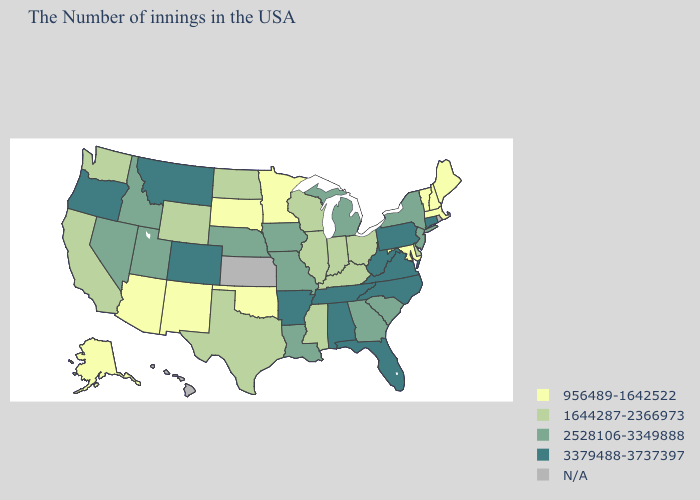What is the value of Missouri?
Answer briefly. 2528106-3349888. Name the states that have a value in the range 2528106-3349888?
Quick response, please. New York, New Jersey, South Carolina, Georgia, Michigan, Louisiana, Missouri, Iowa, Nebraska, Utah, Idaho, Nevada. How many symbols are there in the legend?
Be succinct. 5. Name the states that have a value in the range 1644287-2366973?
Short answer required. Delaware, Ohio, Kentucky, Indiana, Wisconsin, Illinois, Mississippi, Texas, North Dakota, Wyoming, California, Washington. Name the states that have a value in the range 1644287-2366973?
Keep it brief. Delaware, Ohio, Kentucky, Indiana, Wisconsin, Illinois, Mississippi, Texas, North Dakota, Wyoming, California, Washington. What is the lowest value in states that border Missouri?
Be succinct. 956489-1642522. What is the value of Vermont?
Quick response, please. 956489-1642522. What is the lowest value in the USA?
Keep it brief. 956489-1642522. Which states have the lowest value in the USA?
Keep it brief. Maine, Massachusetts, New Hampshire, Vermont, Maryland, Minnesota, Oklahoma, South Dakota, New Mexico, Arizona, Alaska. What is the highest value in the USA?
Answer briefly. 3379488-3737397. Is the legend a continuous bar?
Give a very brief answer. No. What is the value of Hawaii?
Keep it brief. N/A. Name the states that have a value in the range 956489-1642522?
Write a very short answer. Maine, Massachusetts, New Hampshire, Vermont, Maryland, Minnesota, Oklahoma, South Dakota, New Mexico, Arizona, Alaska. What is the highest value in the USA?
Concise answer only. 3379488-3737397. What is the value of California?
Write a very short answer. 1644287-2366973. 